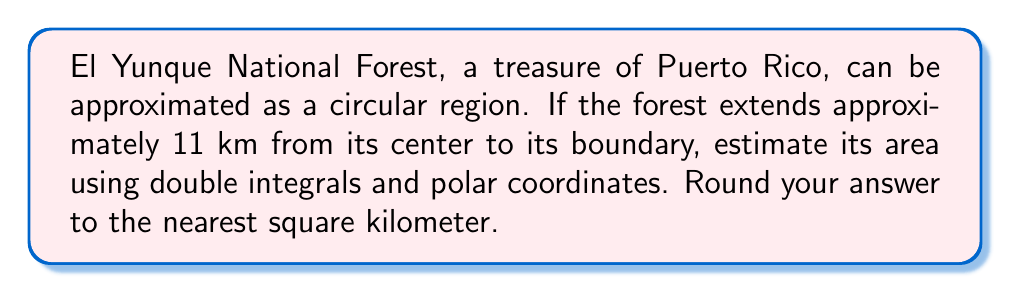Could you help me with this problem? Let's approach this step-by-step:

1) In polar coordinates, the area of a region is given by the double integral:

   $$A = \int_0^{2\pi} \int_0^r r \, dr \, d\theta$$

   where $r$ is the radius and $\theta$ is the angle.

2) We're told that the forest extends 11 km from its center. So, $r = 11$.

3) Substituting this into our integral:

   $$A = \int_0^{2\pi} \int_0^{11} r \, dr \, d\theta$$

4) Let's solve the inner integral first:

   $$A = \int_0^{2\pi} \left[\frac{r^2}{2}\right]_0^{11} \, d\theta$$

5) Evaluating the inner integral:

   $$A = \int_0^{2\pi} \frac{11^2}{2} \, d\theta = \int_0^{2\pi} 60.5 \, d\theta$$

6) Now, solve the outer integral:

   $$A = 60.5 \left[\theta\right]_0^{2\pi} = 60.5 (2\pi - 0) = 121\pi$$

7) This gives us the area in square kilometers. Let's calculate:

   $$A = 121\pi \approx 380.13 \text{ km}^2$$

8) Rounding to the nearest square kilometer:

   $$A \approx 380 \text{ km}^2$$
Answer: $380 \text{ km}^2$ 